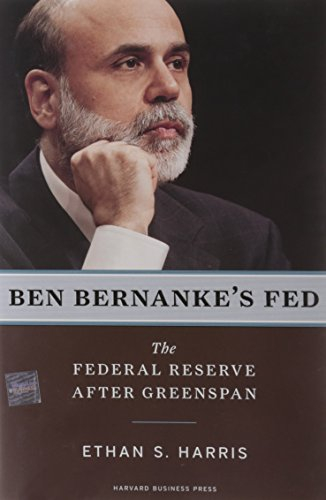Is this a fitness book? No, this book is not related to fitness; it is centered on economic policy and the Federal Reserve's role in financial systems. 